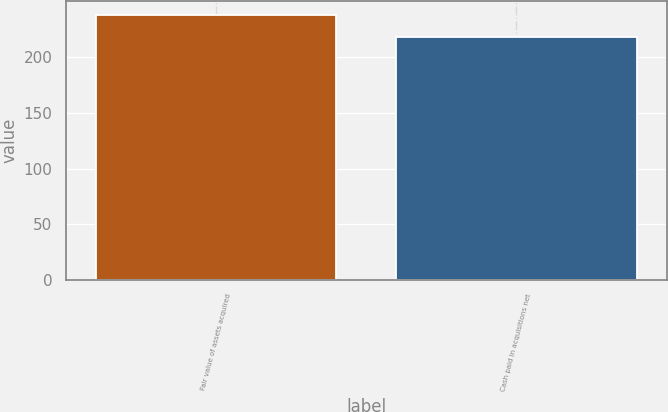Convert chart. <chart><loc_0><loc_0><loc_500><loc_500><bar_chart><fcel>Fair value of assets acquired<fcel>Cash paid in acquisitions net<nl><fcel>238<fcel>218<nl></chart> 